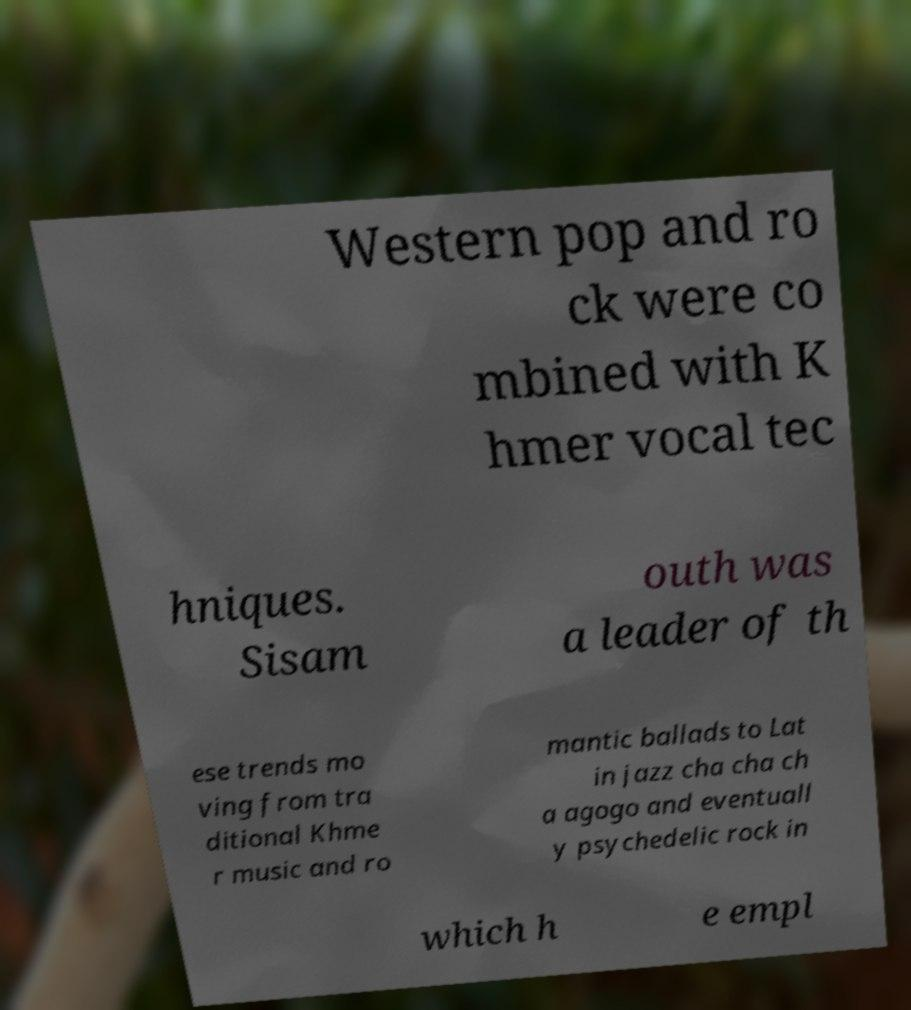I need the written content from this picture converted into text. Can you do that? Western pop and ro ck were co mbined with K hmer vocal tec hniques. Sisam outh was a leader of th ese trends mo ving from tra ditional Khme r music and ro mantic ballads to Lat in jazz cha cha ch a agogo and eventuall y psychedelic rock in which h e empl 